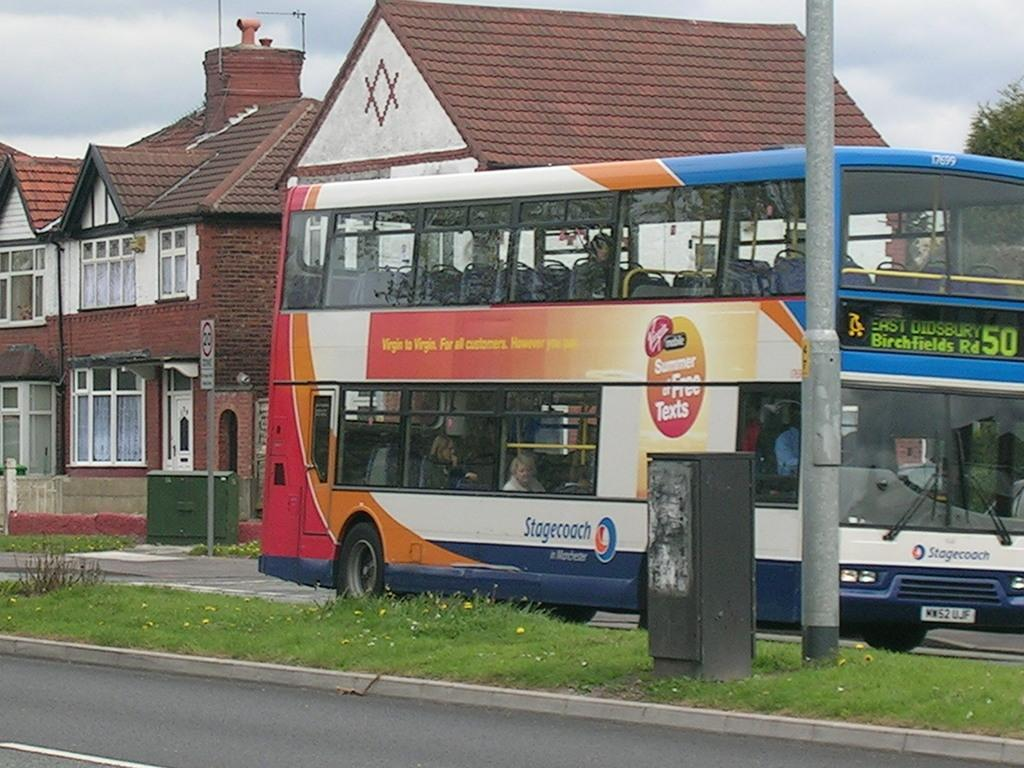Provide a one-sentence caption for the provided image. Stagecoach bus with the number 50 on the front. 